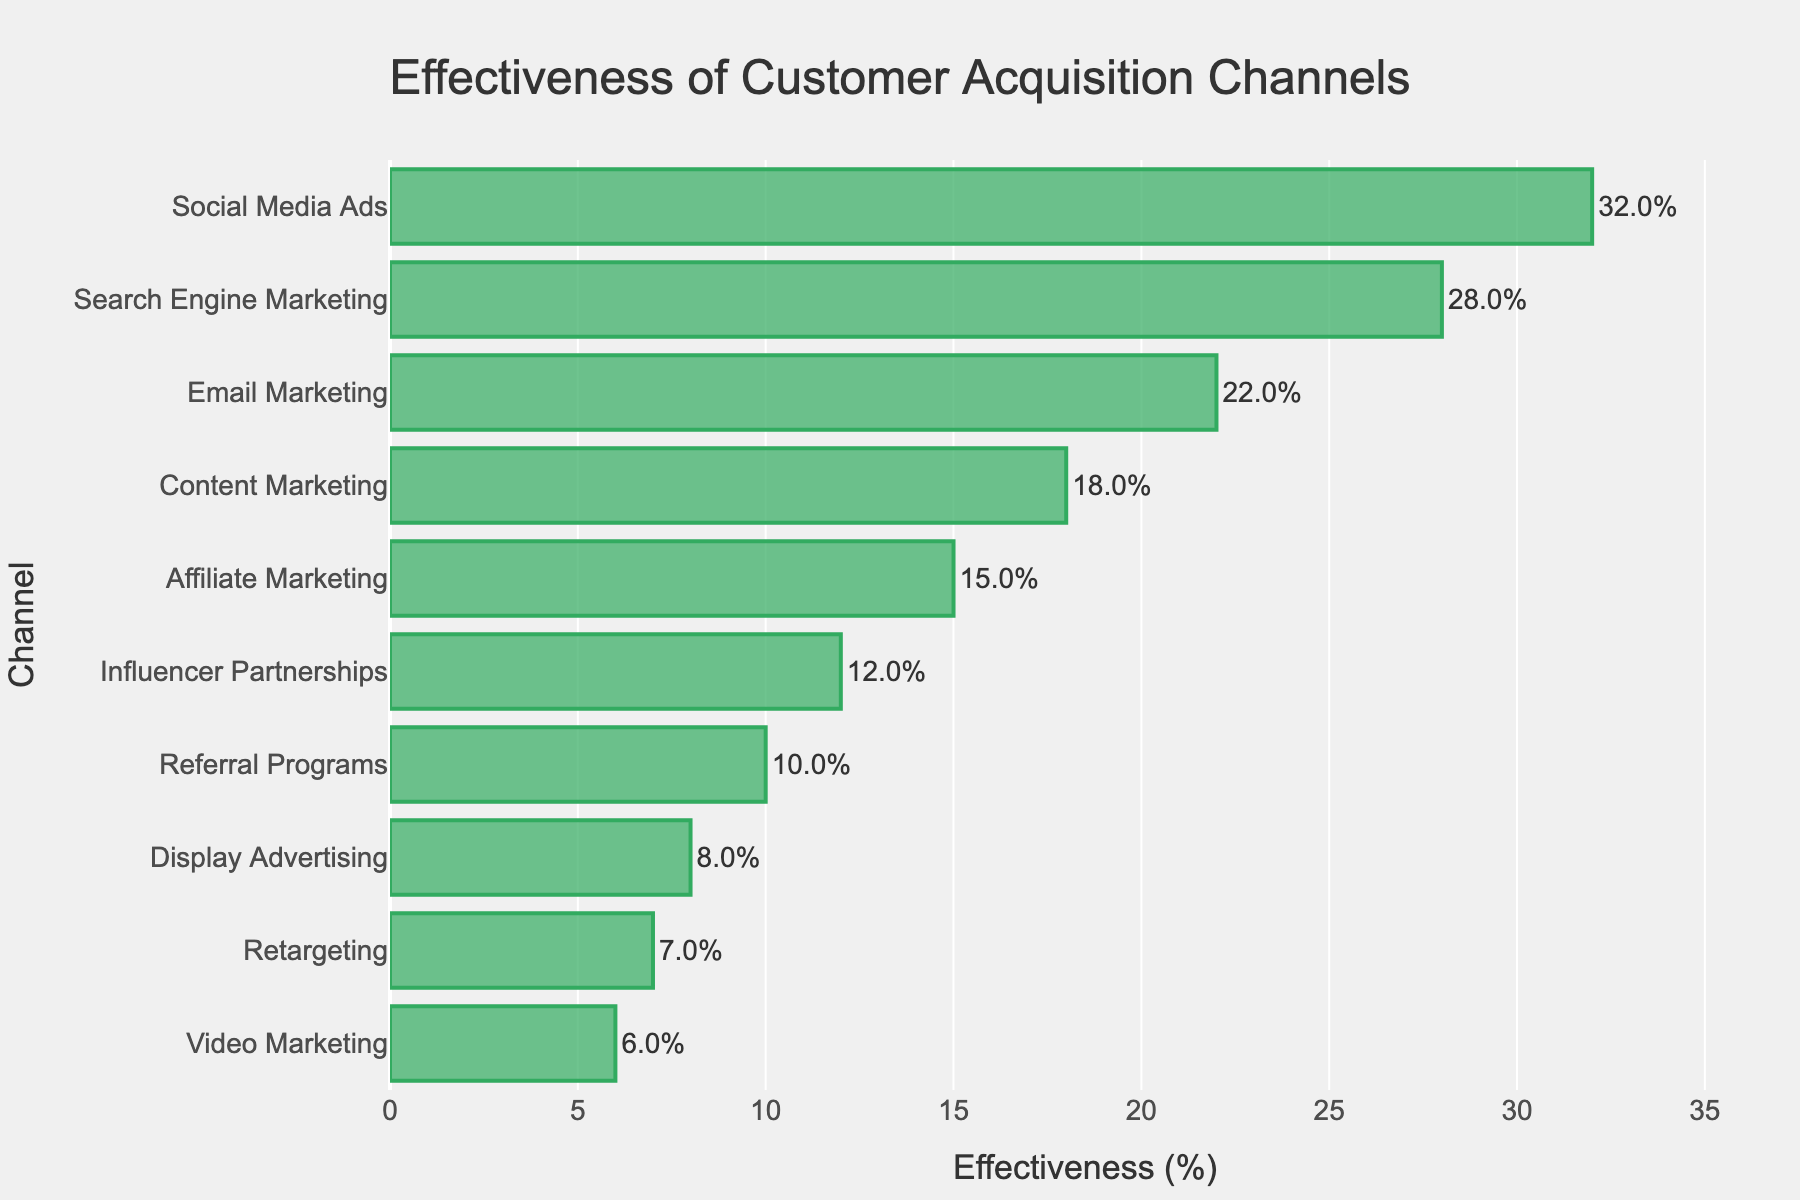Which customer acquisition channel is the most effective? The channel with the highest effectiveness percentage is the most effective. Referring to the bar chart, Social Media Ads has the highest percentage.
Answer: Social Media Ads What is the difference in effectiveness between Social Media Ads and Email Marketing? Social Media Ads has an effectiveness of 32%, and Email Marketing has 22%. The difference is 32% - 22% = 10%.
Answer: 10% How does Search Engine Marketing's effectiveness compare to Content Marketing's? Search Engine Marketing has an effectiveness of 28%, and Content Marketing has 18%. Since 28% is greater than 18%, Search Engine Marketing is more effective.
Answer: Search Engine Marketing is more effective Which acquisition channel has the least effectiveness? The least effective channel is the one with the smallest percentage of effectiveness. Referring to the bar chart, Video Marketing has the lowest percentage at 6%.
Answer: Video Marketing Are there any channels with effectiveness percentages below 10%? If so, what are they? Channels with effectiveness below 10% can be identified by looking at the percentages in the bar chart. Display Advertising (8%), Retargeting (7%), and Video Marketing (6%) are all below 10%.
Answer: Display Advertising, Retargeting, Video Marketing What is the combined effectiveness of Influencer Partnerships and Referral Programs? The effectiveness of Influencer Partnerships is 12%, and Referral Programs is 10%. Their combined effectiveness is 12% + 10% = 22%.
Answer: 22% How much more effective are Social Media Ads compared to Affiliate Marketing? Social Media Ads have an effectiveness of 32%, and Affiliate Marketing has 15%. The difference is 32% - 15% = 17%.
Answer: 17% Which channel has an effectiveness closest to the effectiveness of Email Marketing? Email Marketing has an effectiveness of 22%. Content Marketing has the closest effectiveness at 18%, with a difference of 4%.
Answer: Content Marketing What is the average effectiveness of the top three channels? The top three channels are Social Media Ads (32%), Search Engine Marketing (28%), and Email Marketing (22%). The average is (32 + 28 + 22) / 3 = 27.33%.
Answer: 27.33% Which channels have an effectiveness between 10% and 20%? Channels that fall within the 10% to 20% range can be identified from the figure. Content Marketing (18%), Affiliate Marketing (15%), and Influencer Partnerships (12%) meet this criterion.
Answer: Content Marketing, Affiliate Marketing, Influencer Partnerships 